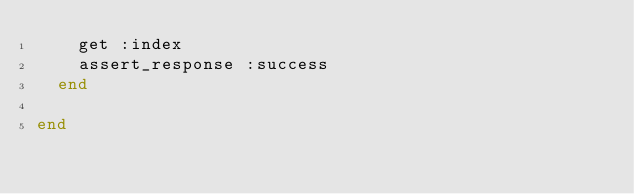Convert code to text. <code><loc_0><loc_0><loc_500><loc_500><_Ruby_>    get :index
    assert_response :success
  end

end
</code> 